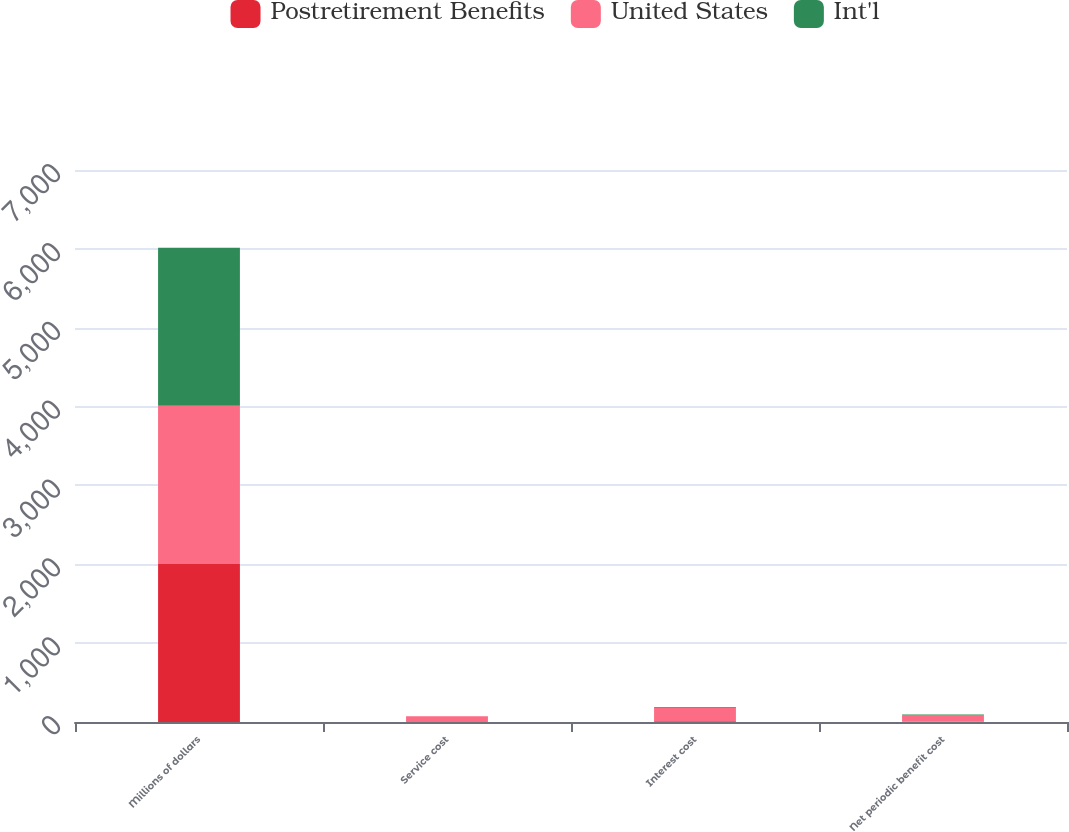<chart> <loc_0><loc_0><loc_500><loc_500><stacked_bar_chart><ecel><fcel>Millions of dollars<fcel>Service cost<fcel>Interest cost<fcel>Net periodic benefit cost<nl><fcel>Postretirement Benefits<fcel>2005<fcel>1<fcel>9<fcel>4<nl><fcel>United States<fcel>2005<fcel>72<fcel>172<fcel>80<nl><fcel>Int'l<fcel>2005<fcel>1<fcel>10<fcel>10<nl></chart> 